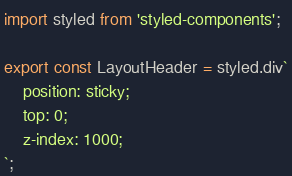Convert code to text. <code><loc_0><loc_0><loc_500><loc_500><_TypeScript_>import styled from 'styled-components';

export const LayoutHeader = styled.div`
    position: sticky;
    top: 0;
    z-index: 1000;
`;
</code> 